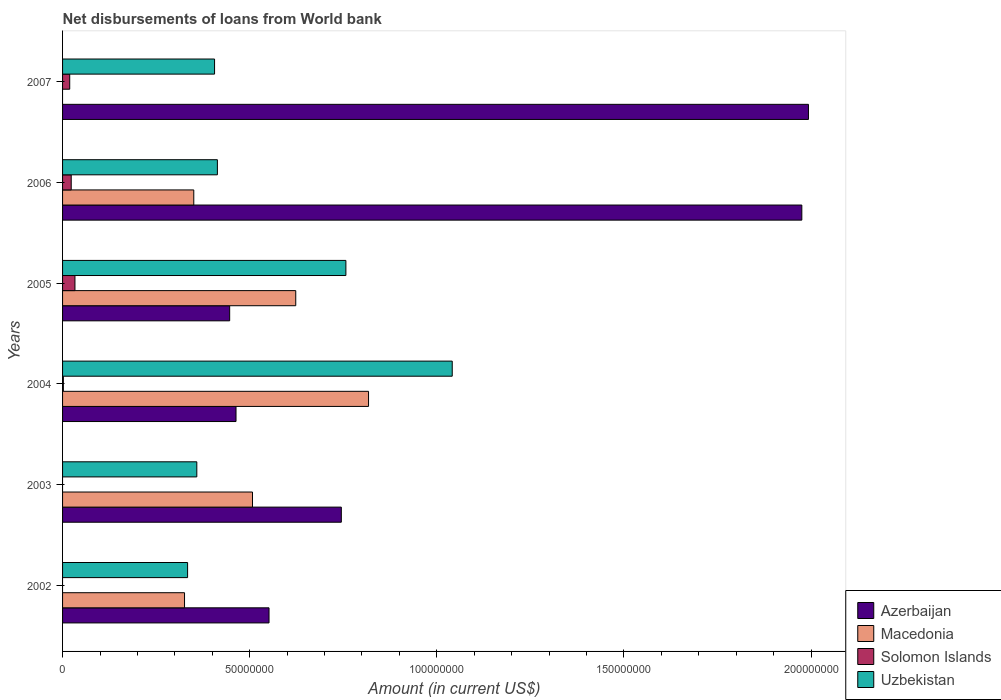Are the number of bars per tick equal to the number of legend labels?
Offer a terse response. No. How many bars are there on the 5th tick from the bottom?
Your answer should be very brief. 4. What is the label of the 4th group of bars from the top?
Offer a terse response. 2004. In how many cases, is the number of bars for a given year not equal to the number of legend labels?
Your answer should be very brief. 3. What is the amount of loan disbursed from World Bank in Azerbaijan in 2004?
Provide a succinct answer. 4.63e+07. Across all years, what is the maximum amount of loan disbursed from World Bank in Azerbaijan?
Keep it short and to the point. 1.99e+08. Across all years, what is the minimum amount of loan disbursed from World Bank in Azerbaijan?
Give a very brief answer. 4.46e+07. What is the total amount of loan disbursed from World Bank in Solomon Islands in the graph?
Give a very brief answer. 7.74e+06. What is the difference between the amount of loan disbursed from World Bank in Solomon Islands in 2004 and that in 2006?
Your answer should be compact. -2.10e+06. What is the difference between the amount of loan disbursed from World Bank in Uzbekistan in 2005 and the amount of loan disbursed from World Bank in Solomon Islands in 2007?
Ensure brevity in your answer.  7.38e+07. What is the average amount of loan disbursed from World Bank in Azerbaijan per year?
Your response must be concise. 1.03e+08. In the year 2005, what is the difference between the amount of loan disbursed from World Bank in Uzbekistan and amount of loan disbursed from World Bank in Azerbaijan?
Provide a short and direct response. 3.11e+07. What is the ratio of the amount of loan disbursed from World Bank in Azerbaijan in 2006 to that in 2007?
Provide a succinct answer. 0.99. Is the amount of loan disbursed from World Bank in Solomon Islands in 2004 less than that in 2007?
Keep it short and to the point. Yes. What is the difference between the highest and the second highest amount of loan disbursed from World Bank in Uzbekistan?
Ensure brevity in your answer.  2.84e+07. What is the difference between the highest and the lowest amount of loan disbursed from World Bank in Solomon Islands?
Give a very brief answer. 3.31e+06. In how many years, is the amount of loan disbursed from World Bank in Azerbaijan greater than the average amount of loan disbursed from World Bank in Azerbaijan taken over all years?
Keep it short and to the point. 2. Is it the case that in every year, the sum of the amount of loan disbursed from World Bank in Solomon Islands and amount of loan disbursed from World Bank in Macedonia is greater than the amount of loan disbursed from World Bank in Azerbaijan?
Give a very brief answer. No. How many bars are there?
Your answer should be very brief. 21. What is the difference between two consecutive major ticks on the X-axis?
Provide a short and direct response. 5.00e+07. Does the graph contain grids?
Ensure brevity in your answer.  No. How many legend labels are there?
Offer a very short reply. 4. How are the legend labels stacked?
Make the answer very short. Vertical. What is the title of the graph?
Give a very brief answer. Net disbursements of loans from World bank. What is the label or title of the X-axis?
Your response must be concise. Amount (in current US$). What is the label or title of the Y-axis?
Offer a very short reply. Years. What is the Amount (in current US$) in Azerbaijan in 2002?
Offer a terse response. 5.52e+07. What is the Amount (in current US$) in Macedonia in 2002?
Provide a succinct answer. 3.26e+07. What is the Amount (in current US$) of Solomon Islands in 2002?
Your answer should be very brief. 0. What is the Amount (in current US$) of Uzbekistan in 2002?
Make the answer very short. 3.34e+07. What is the Amount (in current US$) of Azerbaijan in 2003?
Make the answer very short. 7.45e+07. What is the Amount (in current US$) in Macedonia in 2003?
Provide a succinct answer. 5.07e+07. What is the Amount (in current US$) of Solomon Islands in 2003?
Offer a very short reply. 0. What is the Amount (in current US$) in Uzbekistan in 2003?
Give a very brief answer. 3.59e+07. What is the Amount (in current US$) in Azerbaijan in 2004?
Your answer should be very brief. 4.63e+07. What is the Amount (in current US$) in Macedonia in 2004?
Give a very brief answer. 8.18e+07. What is the Amount (in current US$) of Solomon Islands in 2004?
Your answer should be very brief. 2.13e+05. What is the Amount (in current US$) of Uzbekistan in 2004?
Your answer should be compact. 1.04e+08. What is the Amount (in current US$) in Azerbaijan in 2005?
Your answer should be very brief. 4.46e+07. What is the Amount (in current US$) in Macedonia in 2005?
Your answer should be very brief. 6.23e+07. What is the Amount (in current US$) of Solomon Islands in 2005?
Offer a terse response. 3.31e+06. What is the Amount (in current US$) in Uzbekistan in 2005?
Give a very brief answer. 7.57e+07. What is the Amount (in current US$) of Azerbaijan in 2006?
Ensure brevity in your answer.  1.98e+08. What is the Amount (in current US$) in Macedonia in 2006?
Your response must be concise. 3.51e+07. What is the Amount (in current US$) in Solomon Islands in 2006?
Your answer should be compact. 2.31e+06. What is the Amount (in current US$) in Uzbekistan in 2006?
Your answer should be very brief. 4.14e+07. What is the Amount (in current US$) of Azerbaijan in 2007?
Give a very brief answer. 1.99e+08. What is the Amount (in current US$) in Solomon Islands in 2007?
Offer a terse response. 1.91e+06. What is the Amount (in current US$) in Uzbekistan in 2007?
Give a very brief answer. 4.06e+07. Across all years, what is the maximum Amount (in current US$) in Azerbaijan?
Your response must be concise. 1.99e+08. Across all years, what is the maximum Amount (in current US$) in Macedonia?
Your response must be concise. 8.18e+07. Across all years, what is the maximum Amount (in current US$) of Solomon Islands?
Offer a very short reply. 3.31e+06. Across all years, what is the maximum Amount (in current US$) of Uzbekistan?
Your response must be concise. 1.04e+08. Across all years, what is the minimum Amount (in current US$) of Azerbaijan?
Ensure brevity in your answer.  4.46e+07. Across all years, what is the minimum Amount (in current US$) in Uzbekistan?
Your answer should be compact. 3.34e+07. What is the total Amount (in current US$) in Azerbaijan in the graph?
Your response must be concise. 6.17e+08. What is the total Amount (in current US$) in Macedonia in the graph?
Give a very brief answer. 2.62e+08. What is the total Amount (in current US$) of Solomon Islands in the graph?
Provide a short and direct response. 7.74e+06. What is the total Amount (in current US$) in Uzbekistan in the graph?
Make the answer very short. 3.31e+08. What is the difference between the Amount (in current US$) of Azerbaijan in 2002 and that in 2003?
Ensure brevity in your answer.  -1.93e+07. What is the difference between the Amount (in current US$) in Macedonia in 2002 and that in 2003?
Offer a very short reply. -1.82e+07. What is the difference between the Amount (in current US$) in Uzbekistan in 2002 and that in 2003?
Make the answer very short. -2.46e+06. What is the difference between the Amount (in current US$) of Azerbaijan in 2002 and that in 2004?
Your response must be concise. 8.82e+06. What is the difference between the Amount (in current US$) in Macedonia in 2002 and that in 2004?
Provide a short and direct response. -4.92e+07. What is the difference between the Amount (in current US$) in Uzbekistan in 2002 and that in 2004?
Offer a terse response. -7.07e+07. What is the difference between the Amount (in current US$) of Azerbaijan in 2002 and that in 2005?
Give a very brief answer. 1.05e+07. What is the difference between the Amount (in current US$) in Macedonia in 2002 and that in 2005?
Ensure brevity in your answer.  -2.97e+07. What is the difference between the Amount (in current US$) of Uzbekistan in 2002 and that in 2005?
Provide a short and direct response. -4.23e+07. What is the difference between the Amount (in current US$) in Azerbaijan in 2002 and that in 2006?
Ensure brevity in your answer.  -1.42e+08. What is the difference between the Amount (in current US$) in Macedonia in 2002 and that in 2006?
Offer a very short reply. -2.47e+06. What is the difference between the Amount (in current US$) of Uzbekistan in 2002 and that in 2006?
Offer a very short reply. -7.96e+06. What is the difference between the Amount (in current US$) of Azerbaijan in 2002 and that in 2007?
Offer a terse response. -1.44e+08. What is the difference between the Amount (in current US$) in Uzbekistan in 2002 and that in 2007?
Offer a terse response. -7.21e+06. What is the difference between the Amount (in current US$) in Azerbaijan in 2003 and that in 2004?
Keep it short and to the point. 2.81e+07. What is the difference between the Amount (in current US$) of Macedonia in 2003 and that in 2004?
Offer a terse response. -3.10e+07. What is the difference between the Amount (in current US$) in Uzbekistan in 2003 and that in 2004?
Offer a very short reply. -6.82e+07. What is the difference between the Amount (in current US$) of Azerbaijan in 2003 and that in 2005?
Provide a succinct answer. 2.98e+07. What is the difference between the Amount (in current US$) in Macedonia in 2003 and that in 2005?
Offer a terse response. -1.16e+07. What is the difference between the Amount (in current US$) of Uzbekistan in 2003 and that in 2005?
Your response must be concise. -3.98e+07. What is the difference between the Amount (in current US$) of Azerbaijan in 2003 and that in 2006?
Your answer should be very brief. -1.23e+08. What is the difference between the Amount (in current US$) in Macedonia in 2003 and that in 2006?
Keep it short and to the point. 1.57e+07. What is the difference between the Amount (in current US$) of Uzbekistan in 2003 and that in 2006?
Offer a terse response. -5.50e+06. What is the difference between the Amount (in current US$) in Azerbaijan in 2003 and that in 2007?
Offer a very short reply. -1.25e+08. What is the difference between the Amount (in current US$) in Uzbekistan in 2003 and that in 2007?
Your answer should be very brief. -4.74e+06. What is the difference between the Amount (in current US$) in Azerbaijan in 2004 and that in 2005?
Offer a terse response. 1.70e+06. What is the difference between the Amount (in current US$) of Macedonia in 2004 and that in 2005?
Make the answer very short. 1.94e+07. What is the difference between the Amount (in current US$) of Solomon Islands in 2004 and that in 2005?
Offer a terse response. -3.10e+06. What is the difference between the Amount (in current US$) of Uzbekistan in 2004 and that in 2005?
Ensure brevity in your answer.  2.84e+07. What is the difference between the Amount (in current US$) in Azerbaijan in 2004 and that in 2006?
Offer a very short reply. -1.51e+08. What is the difference between the Amount (in current US$) of Macedonia in 2004 and that in 2006?
Give a very brief answer. 4.67e+07. What is the difference between the Amount (in current US$) in Solomon Islands in 2004 and that in 2006?
Your response must be concise. -2.10e+06. What is the difference between the Amount (in current US$) of Uzbekistan in 2004 and that in 2006?
Make the answer very short. 6.27e+07. What is the difference between the Amount (in current US$) of Azerbaijan in 2004 and that in 2007?
Your response must be concise. -1.53e+08. What is the difference between the Amount (in current US$) of Solomon Islands in 2004 and that in 2007?
Offer a terse response. -1.70e+06. What is the difference between the Amount (in current US$) of Uzbekistan in 2004 and that in 2007?
Ensure brevity in your answer.  6.35e+07. What is the difference between the Amount (in current US$) in Azerbaijan in 2005 and that in 2006?
Provide a succinct answer. -1.53e+08. What is the difference between the Amount (in current US$) of Macedonia in 2005 and that in 2006?
Give a very brief answer. 2.72e+07. What is the difference between the Amount (in current US$) of Solomon Islands in 2005 and that in 2006?
Offer a terse response. 9.98e+05. What is the difference between the Amount (in current US$) of Uzbekistan in 2005 and that in 2006?
Provide a succinct answer. 3.43e+07. What is the difference between the Amount (in current US$) in Azerbaijan in 2005 and that in 2007?
Provide a short and direct response. -1.55e+08. What is the difference between the Amount (in current US$) of Solomon Islands in 2005 and that in 2007?
Make the answer very short. 1.40e+06. What is the difference between the Amount (in current US$) of Uzbekistan in 2005 and that in 2007?
Make the answer very short. 3.51e+07. What is the difference between the Amount (in current US$) of Azerbaijan in 2006 and that in 2007?
Provide a succinct answer. -1.77e+06. What is the difference between the Amount (in current US$) of Solomon Islands in 2006 and that in 2007?
Offer a terse response. 4.01e+05. What is the difference between the Amount (in current US$) of Uzbekistan in 2006 and that in 2007?
Your answer should be compact. 7.56e+05. What is the difference between the Amount (in current US$) in Azerbaijan in 2002 and the Amount (in current US$) in Macedonia in 2003?
Make the answer very short. 4.42e+06. What is the difference between the Amount (in current US$) of Azerbaijan in 2002 and the Amount (in current US$) of Uzbekistan in 2003?
Your answer should be very brief. 1.93e+07. What is the difference between the Amount (in current US$) of Macedonia in 2002 and the Amount (in current US$) of Uzbekistan in 2003?
Offer a terse response. -3.28e+06. What is the difference between the Amount (in current US$) of Azerbaijan in 2002 and the Amount (in current US$) of Macedonia in 2004?
Keep it short and to the point. -2.66e+07. What is the difference between the Amount (in current US$) of Azerbaijan in 2002 and the Amount (in current US$) of Solomon Islands in 2004?
Ensure brevity in your answer.  5.50e+07. What is the difference between the Amount (in current US$) of Azerbaijan in 2002 and the Amount (in current US$) of Uzbekistan in 2004?
Your answer should be compact. -4.90e+07. What is the difference between the Amount (in current US$) in Macedonia in 2002 and the Amount (in current US$) in Solomon Islands in 2004?
Give a very brief answer. 3.24e+07. What is the difference between the Amount (in current US$) of Macedonia in 2002 and the Amount (in current US$) of Uzbekistan in 2004?
Ensure brevity in your answer.  -7.15e+07. What is the difference between the Amount (in current US$) of Azerbaijan in 2002 and the Amount (in current US$) of Macedonia in 2005?
Give a very brief answer. -7.14e+06. What is the difference between the Amount (in current US$) of Azerbaijan in 2002 and the Amount (in current US$) of Solomon Islands in 2005?
Make the answer very short. 5.19e+07. What is the difference between the Amount (in current US$) of Azerbaijan in 2002 and the Amount (in current US$) of Uzbekistan in 2005?
Offer a terse response. -2.05e+07. What is the difference between the Amount (in current US$) in Macedonia in 2002 and the Amount (in current US$) in Solomon Islands in 2005?
Offer a terse response. 2.93e+07. What is the difference between the Amount (in current US$) in Macedonia in 2002 and the Amount (in current US$) in Uzbekistan in 2005?
Your response must be concise. -4.31e+07. What is the difference between the Amount (in current US$) of Azerbaijan in 2002 and the Amount (in current US$) of Macedonia in 2006?
Offer a terse response. 2.01e+07. What is the difference between the Amount (in current US$) of Azerbaijan in 2002 and the Amount (in current US$) of Solomon Islands in 2006?
Your answer should be compact. 5.29e+07. What is the difference between the Amount (in current US$) in Azerbaijan in 2002 and the Amount (in current US$) in Uzbekistan in 2006?
Ensure brevity in your answer.  1.38e+07. What is the difference between the Amount (in current US$) in Macedonia in 2002 and the Amount (in current US$) in Solomon Islands in 2006?
Offer a terse response. 3.03e+07. What is the difference between the Amount (in current US$) of Macedonia in 2002 and the Amount (in current US$) of Uzbekistan in 2006?
Offer a very short reply. -8.78e+06. What is the difference between the Amount (in current US$) in Azerbaijan in 2002 and the Amount (in current US$) in Solomon Islands in 2007?
Keep it short and to the point. 5.33e+07. What is the difference between the Amount (in current US$) in Azerbaijan in 2002 and the Amount (in current US$) in Uzbekistan in 2007?
Provide a short and direct response. 1.46e+07. What is the difference between the Amount (in current US$) in Macedonia in 2002 and the Amount (in current US$) in Solomon Islands in 2007?
Provide a succinct answer. 3.07e+07. What is the difference between the Amount (in current US$) in Macedonia in 2002 and the Amount (in current US$) in Uzbekistan in 2007?
Offer a very short reply. -8.02e+06. What is the difference between the Amount (in current US$) of Azerbaijan in 2003 and the Amount (in current US$) of Macedonia in 2004?
Provide a short and direct response. -7.27e+06. What is the difference between the Amount (in current US$) in Azerbaijan in 2003 and the Amount (in current US$) in Solomon Islands in 2004?
Provide a succinct answer. 7.43e+07. What is the difference between the Amount (in current US$) in Azerbaijan in 2003 and the Amount (in current US$) in Uzbekistan in 2004?
Ensure brevity in your answer.  -2.96e+07. What is the difference between the Amount (in current US$) of Macedonia in 2003 and the Amount (in current US$) of Solomon Islands in 2004?
Give a very brief answer. 5.05e+07. What is the difference between the Amount (in current US$) of Macedonia in 2003 and the Amount (in current US$) of Uzbekistan in 2004?
Provide a succinct answer. -5.34e+07. What is the difference between the Amount (in current US$) in Azerbaijan in 2003 and the Amount (in current US$) in Macedonia in 2005?
Your response must be concise. 1.22e+07. What is the difference between the Amount (in current US$) in Azerbaijan in 2003 and the Amount (in current US$) in Solomon Islands in 2005?
Offer a very short reply. 7.12e+07. What is the difference between the Amount (in current US$) of Azerbaijan in 2003 and the Amount (in current US$) of Uzbekistan in 2005?
Ensure brevity in your answer.  -1.22e+06. What is the difference between the Amount (in current US$) of Macedonia in 2003 and the Amount (in current US$) of Solomon Islands in 2005?
Your response must be concise. 4.74e+07. What is the difference between the Amount (in current US$) of Macedonia in 2003 and the Amount (in current US$) of Uzbekistan in 2005?
Provide a succinct answer. -2.50e+07. What is the difference between the Amount (in current US$) in Azerbaijan in 2003 and the Amount (in current US$) in Macedonia in 2006?
Offer a very short reply. 3.94e+07. What is the difference between the Amount (in current US$) of Azerbaijan in 2003 and the Amount (in current US$) of Solomon Islands in 2006?
Your response must be concise. 7.22e+07. What is the difference between the Amount (in current US$) in Azerbaijan in 2003 and the Amount (in current US$) in Uzbekistan in 2006?
Your response must be concise. 3.31e+07. What is the difference between the Amount (in current US$) of Macedonia in 2003 and the Amount (in current US$) of Solomon Islands in 2006?
Provide a short and direct response. 4.84e+07. What is the difference between the Amount (in current US$) of Macedonia in 2003 and the Amount (in current US$) of Uzbekistan in 2006?
Give a very brief answer. 9.38e+06. What is the difference between the Amount (in current US$) in Azerbaijan in 2003 and the Amount (in current US$) in Solomon Islands in 2007?
Your answer should be very brief. 7.26e+07. What is the difference between the Amount (in current US$) in Azerbaijan in 2003 and the Amount (in current US$) in Uzbekistan in 2007?
Keep it short and to the point. 3.39e+07. What is the difference between the Amount (in current US$) of Macedonia in 2003 and the Amount (in current US$) of Solomon Islands in 2007?
Offer a terse response. 4.88e+07. What is the difference between the Amount (in current US$) of Macedonia in 2003 and the Amount (in current US$) of Uzbekistan in 2007?
Keep it short and to the point. 1.01e+07. What is the difference between the Amount (in current US$) of Azerbaijan in 2004 and the Amount (in current US$) of Macedonia in 2005?
Your answer should be compact. -1.60e+07. What is the difference between the Amount (in current US$) of Azerbaijan in 2004 and the Amount (in current US$) of Solomon Islands in 2005?
Your response must be concise. 4.30e+07. What is the difference between the Amount (in current US$) in Azerbaijan in 2004 and the Amount (in current US$) in Uzbekistan in 2005?
Provide a succinct answer. -2.94e+07. What is the difference between the Amount (in current US$) in Macedonia in 2004 and the Amount (in current US$) in Solomon Islands in 2005?
Provide a short and direct response. 7.84e+07. What is the difference between the Amount (in current US$) of Macedonia in 2004 and the Amount (in current US$) of Uzbekistan in 2005?
Provide a short and direct response. 6.05e+06. What is the difference between the Amount (in current US$) in Solomon Islands in 2004 and the Amount (in current US$) in Uzbekistan in 2005?
Ensure brevity in your answer.  -7.55e+07. What is the difference between the Amount (in current US$) of Azerbaijan in 2004 and the Amount (in current US$) of Macedonia in 2006?
Your response must be concise. 1.13e+07. What is the difference between the Amount (in current US$) in Azerbaijan in 2004 and the Amount (in current US$) in Solomon Islands in 2006?
Offer a terse response. 4.40e+07. What is the difference between the Amount (in current US$) of Azerbaijan in 2004 and the Amount (in current US$) of Uzbekistan in 2006?
Provide a succinct answer. 4.98e+06. What is the difference between the Amount (in current US$) in Macedonia in 2004 and the Amount (in current US$) in Solomon Islands in 2006?
Your response must be concise. 7.94e+07. What is the difference between the Amount (in current US$) in Macedonia in 2004 and the Amount (in current US$) in Uzbekistan in 2006?
Make the answer very short. 4.04e+07. What is the difference between the Amount (in current US$) of Solomon Islands in 2004 and the Amount (in current US$) of Uzbekistan in 2006?
Ensure brevity in your answer.  -4.12e+07. What is the difference between the Amount (in current US$) of Azerbaijan in 2004 and the Amount (in current US$) of Solomon Islands in 2007?
Your answer should be compact. 4.44e+07. What is the difference between the Amount (in current US$) in Azerbaijan in 2004 and the Amount (in current US$) in Uzbekistan in 2007?
Keep it short and to the point. 5.73e+06. What is the difference between the Amount (in current US$) in Macedonia in 2004 and the Amount (in current US$) in Solomon Islands in 2007?
Offer a very short reply. 7.98e+07. What is the difference between the Amount (in current US$) of Macedonia in 2004 and the Amount (in current US$) of Uzbekistan in 2007?
Ensure brevity in your answer.  4.11e+07. What is the difference between the Amount (in current US$) of Solomon Islands in 2004 and the Amount (in current US$) of Uzbekistan in 2007?
Ensure brevity in your answer.  -4.04e+07. What is the difference between the Amount (in current US$) in Azerbaijan in 2005 and the Amount (in current US$) in Macedonia in 2006?
Give a very brief answer. 9.59e+06. What is the difference between the Amount (in current US$) of Azerbaijan in 2005 and the Amount (in current US$) of Solomon Islands in 2006?
Provide a short and direct response. 4.23e+07. What is the difference between the Amount (in current US$) in Azerbaijan in 2005 and the Amount (in current US$) in Uzbekistan in 2006?
Keep it short and to the point. 3.28e+06. What is the difference between the Amount (in current US$) in Macedonia in 2005 and the Amount (in current US$) in Solomon Islands in 2006?
Give a very brief answer. 6.00e+07. What is the difference between the Amount (in current US$) of Macedonia in 2005 and the Amount (in current US$) of Uzbekistan in 2006?
Keep it short and to the point. 2.09e+07. What is the difference between the Amount (in current US$) of Solomon Islands in 2005 and the Amount (in current US$) of Uzbekistan in 2006?
Provide a succinct answer. -3.81e+07. What is the difference between the Amount (in current US$) in Azerbaijan in 2005 and the Amount (in current US$) in Solomon Islands in 2007?
Ensure brevity in your answer.  4.27e+07. What is the difference between the Amount (in current US$) of Azerbaijan in 2005 and the Amount (in current US$) of Uzbekistan in 2007?
Provide a succinct answer. 4.04e+06. What is the difference between the Amount (in current US$) in Macedonia in 2005 and the Amount (in current US$) in Solomon Islands in 2007?
Ensure brevity in your answer.  6.04e+07. What is the difference between the Amount (in current US$) in Macedonia in 2005 and the Amount (in current US$) in Uzbekistan in 2007?
Offer a terse response. 2.17e+07. What is the difference between the Amount (in current US$) of Solomon Islands in 2005 and the Amount (in current US$) of Uzbekistan in 2007?
Keep it short and to the point. -3.73e+07. What is the difference between the Amount (in current US$) of Azerbaijan in 2006 and the Amount (in current US$) of Solomon Islands in 2007?
Provide a succinct answer. 1.96e+08. What is the difference between the Amount (in current US$) in Azerbaijan in 2006 and the Amount (in current US$) in Uzbekistan in 2007?
Keep it short and to the point. 1.57e+08. What is the difference between the Amount (in current US$) in Macedonia in 2006 and the Amount (in current US$) in Solomon Islands in 2007?
Ensure brevity in your answer.  3.32e+07. What is the difference between the Amount (in current US$) in Macedonia in 2006 and the Amount (in current US$) in Uzbekistan in 2007?
Your response must be concise. -5.55e+06. What is the difference between the Amount (in current US$) in Solomon Islands in 2006 and the Amount (in current US$) in Uzbekistan in 2007?
Provide a short and direct response. -3.83e+07. What is the average Amount (in current US$) in Azerbaijan per year?
Provide a short and direct response. 1.03e+08. What is the average Amount (in current US$) in Macedonia per year?
Provide a short and direct response. 4.37e+07. What is the average Amount (in current US$) of Solomon Islands per year?
Make the answer very short. 1.29e+06. What is the average Amount (in current US$) of Uzbekistan per year?
Provide a short and direct response. 5.52e+07. In the year 2002, what is the difference between the Amount (in current US$) of Azerbaijan and Amount (in current US$) of Macedonia?
Provide a short and direct response. 2.26e+07. In the year 2002, what is the difference between the Amount (in current US$) of Azerbaijan and Amount (in current US$) of Uzbekistan?
Keep it short and to the point. 2.18e+07. In the year 2002, what is the difference between the Amount (in current US$) of Macedonia and Amount (in current US$) of Uzbekistan?
Offer a terse response. -8.17e+05. In the year 2003, what is the difference between the Amount (in current US$) of Azerbaijan and Amount (in current US$) of Macedonia?
Give a very brief answer. 2.37e+07. In the year 2003, what is the difference between the Amount (in current US$) in Azerbaijan and Amount (in current US$) in Uzbekistan?
Provide a succinct answer. 3.86e+07. In the year 2003, what is the difference between the Amount (in current US$) in Macedonia and Amount (in current US$) in Uzbekistan?
Offer a terse response. 1.49e+07. In the year 2004, what is the difference between the Amount (in current US$) in Azerbaijan and Amount (in current US$) in Macedonia?
Give a very brief answer. -3.54e+07. In the year 2004, what is the difference between the Amount (in current US$) in Azerbaijan and Amount (in current US$) in Solomon Islands?
Your answer should be very brief. 4.61e+07. In the year 2004, what is the difference between the Amount (in current US$) of Azerbaijan and Amount (in current US$) of Uzbekistan?
Provide a succinct answer. -5.78e+07. In the year 2004, what is the difference between the Amount (in current US$) in Macedonia and Amount (in current US$) in Solomon Islands?
Make the answer very short. 8.15e+07. In the year 2004, what is the difference between the Amount (in current US$) in Macedonia and Amount (in current US$) in Uzbekistan?
Offer a very short reply. -2.24e+07. In the year 2004, what is the difference between the Amount (in current US$) of Solomon Islands and Amount (in current US$) of Uzbekistan?
Your response must be concise. -1.04e+08. In the year 2005, what is the difference between the Amount (in current US$) in Azerbaijan and Amount (in current US$) in Macedonia?
Give a very brief answer. -1.77e+07. In the year 2005, what is the difference between the Amount (in current US$) of Azerbaijan and Amount (in current US$) of Solomon Islands?
Your response must be concise. 4.13e+07. In the year 2005, what is the difference between the Amount (in current US$) in Azerbaijan and Amount (in current US$) in Uzbekistan?
Your response must be concise. -3.11e+07. In the year 2005, what is the difference between the Amount (in current US$) of Macedonia and Amount (in current US$) of Solomon Islands?
Your answer should be compact. 5.90e+07. In the year 2005, what is the difference between the Amount (in current US$) of Macedonia and Amount (in current US$) of Uzbekistan?
Make the answer very short. -1.34e+07. In the year 2005, what is the difference between the Amount (in current US$) in Solomon Islands and Amount (in current US$) in Uzbekistan?
Make the answer very short. -7.24e+07. In the year 2006, what is the difference between the Amount (in current US$) in Azerbaijan and Amount (in current US$) in Macedonia?
Offer a very short reply. 1.62e+08. In the year 2006, what is the difference between the Amount (in current US$) in Azerbaijan and Amount (in current US$) in Solomon Islands?
Ensure brevity in your answer.  1.95e+08. In the year 2006, what is the difference between the Amount (in current US$) of Azerbaijan and Amount (in current US$) of Uzbekistan?
Your response must be concise. 1.56e+08. In the year 2006, what is the difference between the Amount (in current US$) in Macedonia and Amount (in current US$) in Solomon Islands?
Give a very brief answer. 3.27e+07. In the year 2006, what is the difference between the Amount (in current US$) of Macedonia and Amount (in current US$) of Uzbekistan?
Your response must be concise. -6.31e+06. In the year 2006, what is the difference between the Amount (in current US$) in Solomon Islands and Amount (in current US$) in Uzbekistan?
Keep it short and to the point. -3.91e+07. In the year 2007, what is the difference between the Amount (in current US$) in Azerbaijan and Amount (in current US$) in Solomon Islands?
Give a very brief answer. 1.97e+08. In the year 2007, what is the difference between the Amount (in current US$) in Azerbaijan and Amount (in current US$) in Uzbekistan?
Offer a very short reply. 1.59e+08. In the year 2007, what is the difference between the Amount (in current US$) of Solomon Islands and Amount (in current US$) of Uzbekistan?
Ensure brevity in your answer.  -3.87e+07. What is the ratio of the Amount (in current US$) of Azerbaijan in 2002 to that in 2003?
Give a very brief answer. 0.74. What is the ratio of the Amount (in current US$) of Macedonia in 2002 to that in 2003?
Ensure brevity in your answer.  0.64. What is the ratio of the Amount (in current US$) of Uzbekistan in 2002 to that in 2003?
Ensure brevity in your answer.  0.93. What is the ratio of the Amount (in current US$) of Azerbaijan in 2002 to that in 2004?
Your answer should be compact. 1.19. What is the ratio of the Amount (in current US$) of Macedonia in 2002 to that in 2004?
Offer a terse response. 0.4. What is the ratio of the Amount (in current US$) of Uzbekistan in 2002 to that in 2004?
Keep it short and to the point. 0.32. What is the ratio of the Amount (in current US$) in Azerbaijan in 2002 to that in 2005?
Ensure brevity in your answer.  1.24. What is the ratio of the Amount (in current US$) of Macedonia in 2002 to that in 2005?
Provide a short and direct response. 0.52. What is the ratio of the Amount (in current US$) in Uzbekistan in 2002 to that in 2005?
Your answer should be very brief. 0.44. What is the ratio of the Amount (in current US$) of Azerbaijan in 2002 to that in 2006?
Your response must be concise. 0.28. What is the ratio of the Amount (in current US$) of Macedonia in 2002 to that in 2006?
Make the answer very short. 0.93. What is the ratio of the Amount (in current US$) in Uzbekistan in 2002 to that in 2006?
Your answer should be very brief. 0.81. What is the ratio of the Amount (in current US$) of Azerbaijan in 2002 to that in 2007?
Make the answer very short. 0.28. What is the ratio of the Amount (in current US$) in Uzbekistan in 2002 to that in 2007?
Offer a very short reply. 0.82. What is the ratio of the Amount (in current US$) of Azerbaijan in 2003 to that in 2004?
Your answer should be compact. 1.61. What is the ratio of the Amount (in current US$) of Macedonia in 2003 to that in 2004?
Your answer should be very brief. 0.62. What is the ratio of the Amount (in current US$) of Uzbekistan in 2003 to that in 2004?
Make the answer very short. 0.34. What is the ratio of the Amount (in current US$) of Azerbaijan in 2003 to that in 2005?
Your response must be concise. 1.67. What is the ratio of the Amount (in current US$) of Macedonia in 2003 to that in 2005?
Make the answer very short. 0.81. What is the ratio of the Amount (in current US$) of Uzbekistan in 2003 to that in 2005?
Provide a short and direct response. 0.47. What is the ratio of the Amount (in current US$) of Azerbaijan in 2003 to that in 2006?
Make the answer very short. 0.38. What is the ratio of the Amount (in current US$) in Macedonia in 2003 to that in 2006?
Offer a very short reply. 1.45. What is the ratio of the Amount (in current US$) of Uzbekistan in 2003 to that in 2006?
Keep it short and to the point. 0.87. What is the ratio of the Amount (in current US$) in Azerbaijan in 2003 to that in 2007?
Your response must be concise. 0.37. What is the ratio of the Amount (in current US$) of Uzbekistan in 2003 to that in 2007?
Your answer should be very brief. 0.88. What is the ratio of the Amount (in current US$) of Azerbaijan in 2004 to that in 2005?
Your answer should be compact. 1.04. What is the ratio of the Amount (in current US$) in Macedonia in 2004 to that in 2005?
Provide a short and direct response. 1.31. What is the ratio of the Amount (in current US$) of Solomon Islands in 2004 to that in 2005?
Offer a very short reply. 0.06. What is the ratio of the Amount (in current US$) in Uzbekistan in 2004 to that in 2005?
Make the answer very short. 1.38. What is the ratio of the Amount (in current US$) of Azerbaijan in 2004 to that in 2006?
Keep it short and to the point. 0.23. What is the ratio of the Amount (in current US$) of Macedonia in 2004 to that in 2006?
Offer a terse response. 2.33. What is the ratio of the Amount (in current US$) in Solomon Islands in 2004 to that in 2006?
Offer a very short reply. 0.09. What is the ratio of the Amount (in current US$) of Uzbekistan in 2004 to that in 2006?
Offer a terse response. 2.52. What is the ratio of the Amount (in current US$) in Azerbaijan in 2004 to that in 2007?
Your answer should be very brief. 0.23. What is the ratio of the Amount (in current US$) of Solomon Islands in 2004 to that in 2007?
Your answer should be very brief. 0.11. What is the ratio of the Amount (in current US$) of Uzbekistan in 2004 to that in 2007?
Give a very brief answer. 2.56. What is the ratio of the Amount (in current US$) of Azerbaijan in 2005 to that in 2006?
Offer a very short reply. 0.23. What is the ratio of the Amount (in current US$) in Macedonia in 2005 to that in 2006?
Give a very brief answer. 1.78. What is the ratio of the Amount (in current US$) of Solomon Islands in 2005 to that in 2006?
Ensure brevity in your answer.  1.43. What is the ratio of the Amount (in current US$) in Uzbekistan in 2005 to that in 2006?
Your answer should be very brief. 1.83. What is the ratio of the Amount (in current US$) in Azerbaijan in 2005 to that in 2007?
Keep it short and to the point. 0.22. What is the ratio of the Amount (in current US$) of Solomon Islands in 2005 to that in 2007?
Your answer should be very brief. 1.73. What is the ratio of the Amount (in current US$) of Uzbekistan in 2005 to that in 2007?
Give a very brief answer. 1.86. What is the ratio of the Amount (in current US$) in Azerbaijan in 2006 to that in 2007?
Keep it short and to the point. 0.99. What is the ratio of the Amount (in current US$) of Solomon Islands in 2006 to that in 2007?
Give a very brief answer. 1.21. What is the ratio of the Amount (in current US$) of Uzbekistan in 2006 to that in 2007?
Your response must be concise. 1.02. What is the difference between the highest and the second highest Amount (in current US$) in Azerbaijan?
Offer a terse response. 1.77e+06. What is the difference between the highest and the second highest Amount (in current US$) of Macedonia?
Your answer should be compact. 1.94e+07. What is the difference between the highest and the second highest Amount (in current US$) in Solomon Islands?
Ensure brevity in your answer.  9.98e+05. What is the difference between the highest and the second highest Amount (in current US$) of Uzbekistan?
Your answer should be very brief. 2.84e+07. What is the difference between the highest and the lowest Amount (in current US$) in Azerbaijan?
Provide a short and direct response. 1.55e+08. What is the difference between the highest and the lowest Amount (in current US$) in Macedonia?
Your response must be concise. 8.18e+07. What is the difference between the highest and the lowest Amount (in current US$) in Solomon Islands?
Your answer should be very brief. 3.31e+06. What is the difference between the highest and the lowest Amount (in current US$) in Uzbekistan?
Offer a terse response. 7.07e+07. 